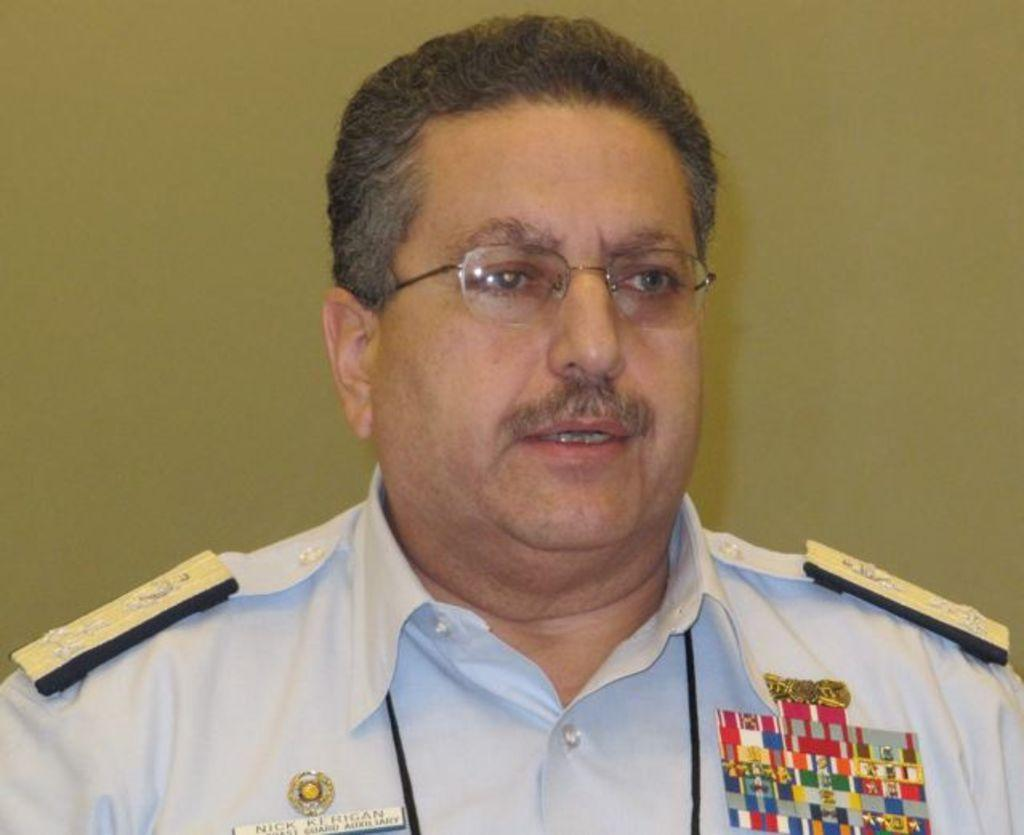Who or what is the main subject in the image? There is a person in the image. Can you describe the position of the person in the image? The person is in the middle of the image. What is visible behind the person? There is a wall behind the person. What type of toothpaste is the person using in the image? There is no toothpaste present in the image. What color is the skirt the person is wearing in the image? There is no skirt visible in the image. 